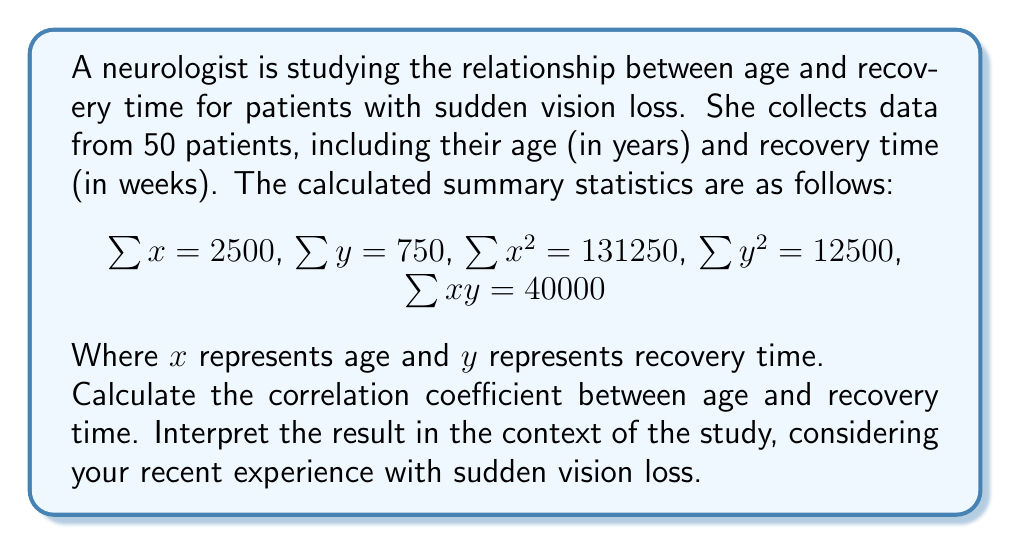Solve this math problem. To calculate the correlation coefficient, we'll use the formula:

$$r = \frac{n\sum xy - \sum x \sum y}{\sqrt{[n\sum x^2 - (\sum x)^2][n\sum y^2 - (\sum y)^2]}}$$

Where $n$ is the number of patients (50 in this case).

Step 1: Calculate $n\sum xy$
$n\sum xy = 50 \times 40000 = 2000000$

Step 2: Calculate $\sum x \sum y$
$\sum x \sum y = 2500 \times 750 = 1875000$

Step 3: Calculate the numerator
$2000000 - 1875000 = 125000$

Step 4: Calculate $n\sum x^2$ and $(\sum x)^2$
$n\sum x^2 = 50 \times 131250 = 6562500$
$(\sum x)^2 = 2500^2 = 6250000$

Step 5: Calculate $n\sum y^2$ and $(\sum y)^2$
$n\sum y^2 = 50 \times 12500 = 625000$
$(\sum y)^2 = 750^2 = 562500$

Step 6: Calculate the denominator
$\sqrt{[6562500 - 6250000][625000 - 562500]} = \sqrt{312500 \times 62500} = \sqrt{19531250000} = 139750$

Step 7: Calculate the correlation coefficient
$$r = \frac{125000}{139750} \approx 0.8944$$

Interpretation: The correlation coefficient of approximately 0.89 indicates a strong positive correlation between age and recovery time for vision loss patients. This suggests that as age increases, the recovery time tends to increase as well. 

For a middle-aged woman who recently experienced sudden vision loss, this information could be valuable in setting expectations for recovery. It implies that older patients may generally require more time to recover compared to younger patients. However, it's important to note that correlation does not imply causation, and individual experiences may vary.
Answer: The correlation coefficient between age and recovery time is approximately 0.89, indicating a strong positive correlation. 